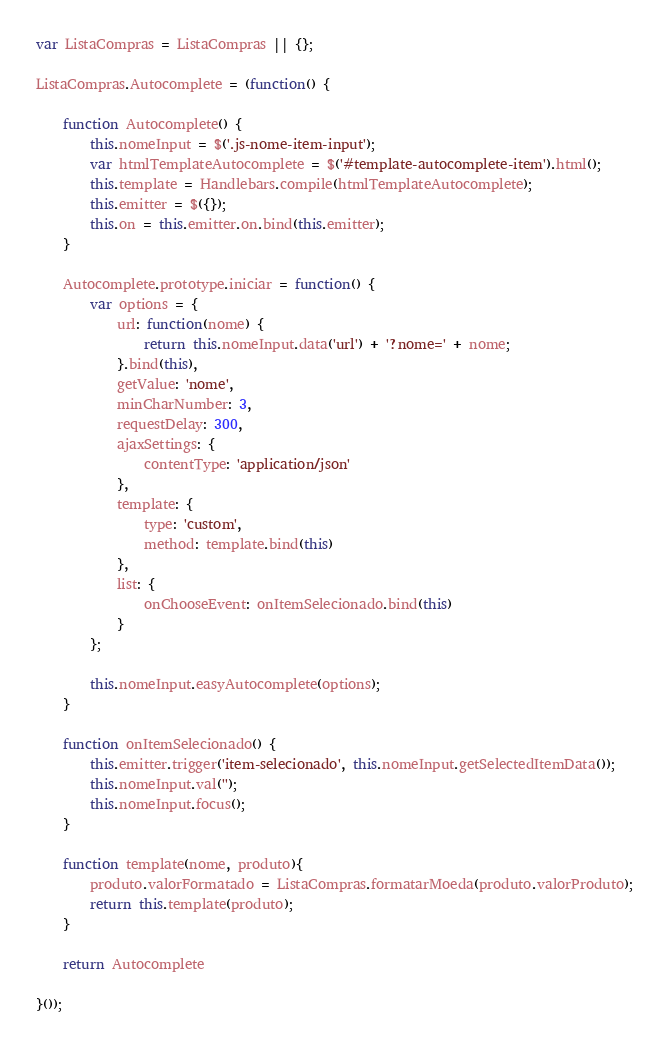<code> <loc_0><loc_0><loc_500><loc_500><_JavaScript_>var ListaCompras = ListaCompras || {};

ListaCompras.Autocomplete = (function() {
	
	function Autocomplete() {
		this.nomeInput = $('.js-nome-item-input');
		var htmlTemplateAutocomplete = $('#template-autocomplete-item').html();
		this.template = Handlebars.compile(htmlTemplateAutocomplete);
		this.emitter = $({});
		this.on = this.emitter.on.bind(this.emitter);
	}
	
	Autocomplete.prototype.iniciar = function() {
		var options = {
			url: function(nome) {
				return this.nomeInput.data('url') + '?nome=' + nome;
			}.bind(this),
			getValue: 'nome',
			minCharNumber: 3,
			requestDelay: 300,
			ajaxSettings: {
				contentType: 'application/json'
			},
			template: {
				type: 'custom',
				method: template.bind(this)
			},
			list: {
				onChooseEvent: onItemSelecionado.bind(this)
			}
		};
		
		this.nomeInput.easyAutocomplete(options);
	}

	function onItemSelecionado() {
		this.emitter.trigger('item-selecionado', this.nomeInput.getSelectedItemData());
		this.nomeInput.val('');
		this.nomeInput.focus();
	}
	
	function template(nome, produto){
		produto.valorFormatado = ListaCompras.formatarMoeda(produto.valorProduto);
		return this.template(produto);
	}
		
	return Autocomplete
	
}());
</code> 